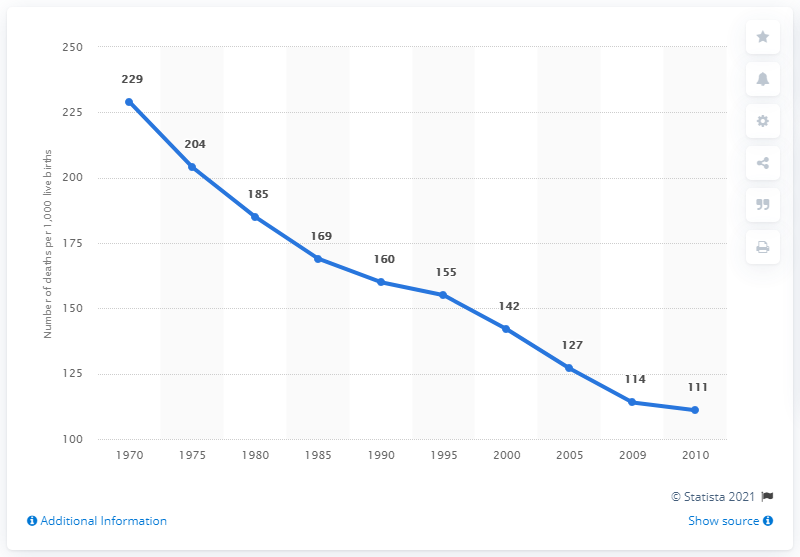Point out several critical features in this image. In 2010, the child mortality rate per 1,000 live births was 111. In 1970, the child mortality rate per 1,000 live births was 229. 